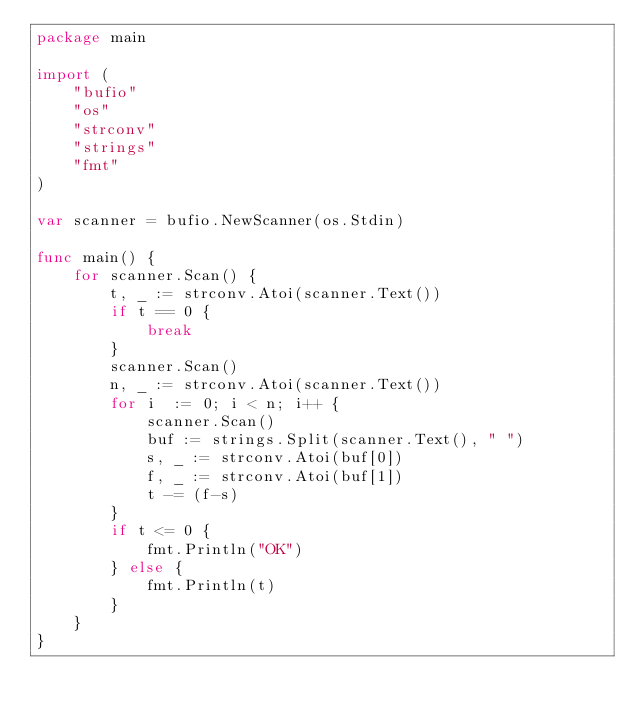Convert code to text. <code><loc_0><loc_0><loc_500><loc_500><_Go_>package main

import (
	"bufio"
	"os"
	"strconv"
	"strings"
	"fmt"
)

var scanner = bufio.NewScanner(os.Stdin)

func main() {
	for scanner.Scan() {
		t, _ := strconv.Atoi(scanner.Text())
		if t == 0 {
			break
		}
		scanner.Scan()
		n, _ := strconv.Atoi(scanner.Text())
		for i  := 0; i < n; i++ {
			scanner.Scan()
			buf := strings.Split(scanner.Text(), " ")
			s, _ := strconv.Atoi(buf[0])
			f, _ := strconv.Atoi(buf[1])
			t -= (f-s)
		}
		if t <= 0 {
			fmt.Println("OK")
		} else {
			fmt.Println(t)
		}
	}
}
</code> 